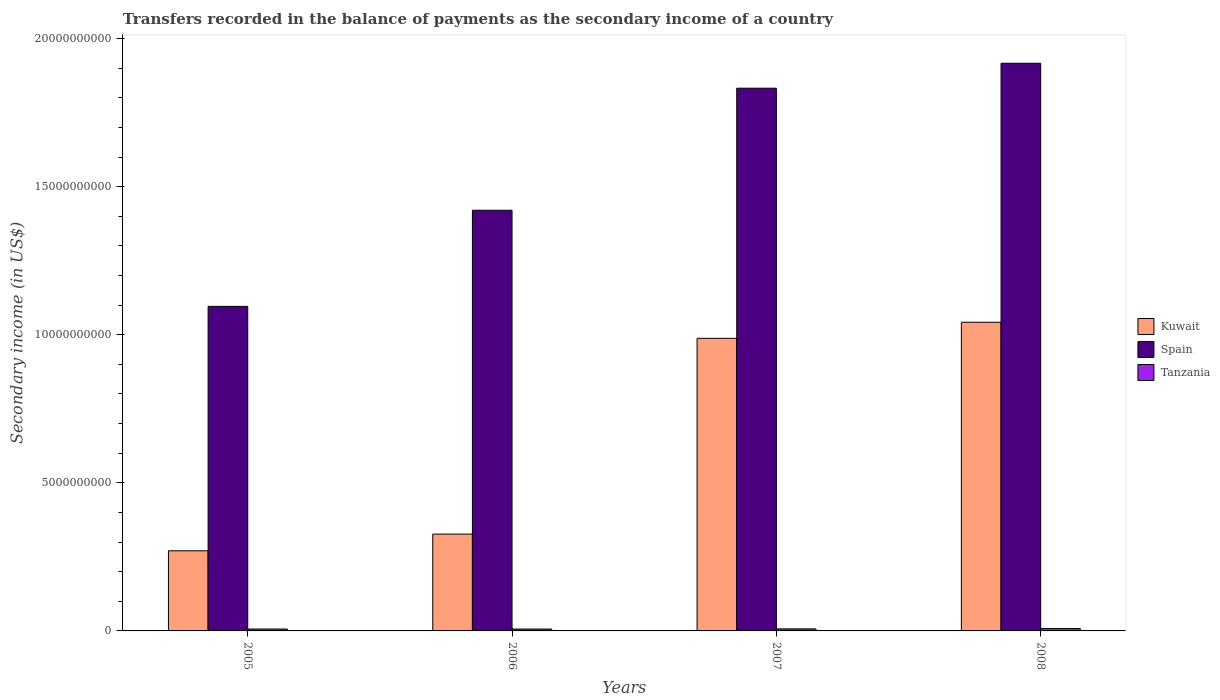How many different coloured bars are there?
Offer a very short reply. 3. Are the number of bars per tick equal to the number of legend labels?
Your answer should be compact. Yes. Are the number of bars on each tick of the X-axis equal?
Make the answer very short. Yes. How many bars are there on the 2nd tick from the left?
Make the answer very short. 3. What is the label of the 1st group of bars from the left?
Keep it short and to the point. 2005. In how many cases, is the number of bars for a given year not equal to the number of legend labels?
Keep it short and to the point. 0. What is the secondary income of in Tanzania in 2006?
Offer a terse response. 6.35e+07. Across all years, what is the maximum secondary income of in Spain?
Make the answer very short. 1.92e+1. Across all years, what is the minimum secondary income of in Tanzania?
Keep it short and to the point. 6.35e+07. In which year was the secondary income of in Spain minimum?
Keep it short and to the point. 2005. What is the total secondary income of in Kuwait in the graph?
Offer a very short reply. 2.63e+1. What is the difference between the secondary income of in Tanzania in 2005 and that in 2006?
Offer a terse response. 4.24e+05. What is the difference between the secondary income of in Kuwait in 2008 and the secondary income of in Spain in 2005?
Offer a terse response. -5.35e+08. What is the average secondary income of in Spain per year?
Provide a succinct answer. 1.57e+1. In the year 2007, what is the difference between the secondary income of in Kuwait and secondary income of in Spain?
Offer a very short reply. -8.45e+09. In how many years, is the secondary income of in Kuwait greater than 1000000000 US$?
Keep it short and to the point. 4. What is the ratio of the secondary income of in Kuwait in 2005 to that in 2007?
Your answer should be very brief. 0.27. Is the secondary income of in Kuwait in 2005 less than that in 2007?
Make the answer very short. Yes. Is the difference between the secondary income of in Kuwait in 2005 and 2007 greater than the difference between the secondary income of in Spain in 2005 and 2007?
Provide a short and direct response. Yes. What is the difference between the highest and the second highest secondary income of in Kuwait?
Offer a very short reply. 5.42e+08. What is the difference between the highest and the lowest secondary income of in Kuwait?
Your answer should be compact. 7.72e+09. Is the sum of the secondary income of in Tanzania in 2005 and 2006 greater than the maximum secondary income of in Kuwait across all years?
Provide a succinct answer. No. What does the 1st bar from the left in 2008 represents?
Make the answer very short. Kuwait. How many bars are there?
Ensure brevity in your answer.  12. Are all the bars in the graph horizontal?
Make the answer very short. No. How many years are there in the graph?
Your answer should be very brief. 4. What is the difference between two consecutive major ticks on the Y-axis?
Your response must be concise. 5.00e+09. Does the graph contain any zero values?
Offer a terse response. No. Does the graph contain grids?
Make the answer very short. No. Where does the legend appear in the graph?
Provide a short and direct response. Center right. What is the title of the graph?
Provide a short and direct response. Transfers recorded in the balance of payments as the secondary income of a country. What is the label or title of the Y-axis?
Ensure brevity in your answer.  Secondary income (in US$). What is the Secondary income (in US$) in Kuwait in 2005?
Give a very brief answer. 2.71e+09. What is the Secondary income (in US$) in Spain in 2005?
Your answer should be very brief. 1.10e+1. What is the Secondary income (in US$) of Tanzania in 2005?
Keep it short and to the point. 6.40e+07. What is the Secondary income (in US$) in Kuwait in 2006?
Provide a succinct answer. 3.27e+09. What is the Secondary income (in US$) in Spain in 2006?
Your answer should be very brief. 1.42e+1. What is the Secondary income (in US$) in Tanzania in 2006?
Offer a very short reply. 6.35e+07. What is the Secondary income (in US$) in Kuwait in 2007?
Give a very brief answer. 9.88e+09. What is the Secondary income (in US$) in Spain in 2007?
Give a very brief answer. 1.83e+1. What is the Secondary income (in US$) in Tanzania in 2007?
Provide a succinct answer. 6.88e+07. What is the Secondary income (in US$) of Kuwait in 2008?
Your answer should be very brief. 1.04e+1. What is the Secondary income (in US$) of Spain in 2008?
Ensure brevity in your answer.  1.92e+1. What is the Secondary income (in US$) of Tanzania in 2008?
Provide a short and direct response. 7.91e+07. Across all years, what is the maximum Secondary income (in US$) in Kuwait?
Ensure brevity in your answer.  1.04e+1. Across all years, what is the maximum Secondary income (in US$) in Spain?
Make the answer very short. 1.92e+1. Across all years, what is the maximum Secondary income (in US$) of Tanzania?
Keep it short and to the point. 7.91e+07. Across all years, what is the minimum Secondary income (in US$) of Kuwait?
Ensure brevity in your answer.  2.71e+09. Across all years, what is the minimum Secondary income (in US$) of Spain?
Your answer should be compact. 1.10e+1. Across all years, what is the minimum Secondary income (in US$) of Tanzania?
Make the answer very short. 6.35e+07. What is the total Secondary income (in US$) in Kuwait in the graph?
Provide a succinct answer. 2.63e+1. What is the total Secondary income (in US$) in Spain in the graph?
Keep it short and to the point. 6.27e+1. What is the total Secondary income (in US$) in Tanzania in the graph?
Offer a terse response. 2.75e+08. What is the difference between the Secondary income (in US$) in Kuwait in 2005 and that in 2006?
Your answer should be compact. -5.64e+08. What is the difference between the Secondary income (in US$) in Spain in 2005 and that in 2006?
Ensure brevity in your answer.  -3.25e+09. What is the difference between the Secondary income (in US$) of Tanzania in 2005 and that in 2006?
Ensure brevity in your answer.  4.24e+05. What is the difference between the Secondary income (in US$) of Kuwait in 2005 and that in 2007?
Make the answer very short. -7.17e+09. What is the difference between the Secondary income (in US$) of Spain in 2005 and that in 2007?
Provide a succinct answer. -7.37e+09. What is the difference between the Secondary income (in US$) in Tanzania in 2005 and that in 2007?
Provide a short and direct response. -4.82e+06. What is the difference between the Secondary income (in US$) in Kuwait in 2005 and that in 2008?
Give a very brief answer. -7.72e+09. What is the difference between the Secondary income (in US$) in Spain in 2005 and that in 2008?
Offer a very short reply. -8.21e+09. What is the difference between the Secondary income (in US$) in Tanzania in 2005 and that in 2008?
Keep it short and to the point. -1.52e+07. What is the difference between the Secondary income (in US$) of Kuwait in 2006 and that in 2007?
Your response must be concise. -6.61e+09. What is the difference between the Secondary income (in US$) in Spain in 2006 and that in 2007?
Your answer should be very brief. -4.12e+09. What is the difference between the Secondary income (in US$) in Tanzania in 2006 and that in 2007?
Provide a succinct answer. -5.25e+06. What is the difference between the Secondary income (in US$) of Kuwait in 2006 and that in 2008?
Offer a very short reply. -7.15e+09. What is the difference between the Secondary income (in US$) of Spain in 2006 and that in 2008?
Provide a succinct answer. -4.96e+09. What is the difference between the Secondary income (in US$) in Tanzania in 2006 and that in 2008?
Keep it short and to the point. -1.56e+07. What is the difference between the Secondary income (in US$) of Kuwait in 2007 and that in 2008?
Provide a short and direct response. -5.42e+08. What is the difference between the Secondary income (in US$) of Spain in 2007 and that in 2008?
Give a very brief answer. -8.42e+08. What is the difference between the Secondary income (in US$) of Tanzania in 2007 and that in 2008?
Keep it short and to the point. -1.04e+07. What is the difference between the Secondary income (in US$) of Kuwait in 2005 and the Secondary income (in US$) of Spain in 2006?
Offer a terse response. -1.15e+1. What is the difference between the Secondary income (in US$) of Kuwait in 2005 and the Secondary income (in US$) of Tanzania in 2006?
Your answer should be compact. 2.64e+09. What is the difference between the Secondary income (in US$) in Spain in 2005 and the Secondary income (in US$) in Tanzania in 2006?
Offer a terse response. 1.09e+1. What is the difference between the Secondary income (in US$) in Kuwait in 2005 and the Secondary income (in US$) in Spain in 2007?
Offer a terse response. -1.56e+1. What is the difference between the Secondary income (in US$) of Kuwait in 2005 and the Secondary income (in US$) of Tanzania in 2007?
Your response must be concise. 2.64e+09. What is the difference between the Secondary income (in US$) in Spain in 2005 and the Secondary income (in US$) in Tanzania in 2007?
Give a very brief answer. 1.09e+1. What is the difference between the Secondary income (in US$) of Kuwait in 2005 and the Secondary income (in US$) of Spain in 2008?
Your answer should be compact. -1.65e+1. What is the difference between the Secondary income (in US$) in Kuwait in 2005 and the Secondary income (in US$) in Tanzania in 2008?
Your answer should be very brief. 2.63e+09. What is the difference between the Secondary income (in US$) in Spain in 2005 and the Secondary income (in US$) in Tanzania in 2008?
Provide a succinct answer. 1.09e+1. What is the difference between the Secondary income (in US$) of Kuwait in 2006 and the Secondary income (in US$) of Spain in 2007?
Your response must be concise. -1.51e+1. What is the difference between the Secondary income (in US$) in Kuwait in 2006 and the Secondary income (in US$) in Tanzania in 2007?
Keep it short and to the point. 3.20e+09. What is the difference between the Secondary income (in US$) of Spain in 2006 and the Secondary income (in US$) of Tanzania in 2007?
Your answer should be very brief. 1.41e+1. What is the difference between the Secondary income (in US$) of Kuwait in 2006 and the Secondary income (in US$) of Spain in 2008?
Keep it short and to the point. -1.59e+1. What is the difference between the Secondary income (in US$) of Kuwait in 2006 and the Secondary income (in US$) of Tanzania in 2008?
Offer a terse response. 3.19e+09. What is the difference between the Secondary income (in US$) of Spain in 2006 and the Secondary income (in US$) of Tanzania in 2008?
Your response must be concise. 1.41e+1. What is the difference between the Secondary income (in US$) in Kuwait in 2007 and the Secondary income (in US$) in Spain in 2008?
Provide a succinct answer. -9.29e+09. What is the difference between the Secondary income (in US$) of Kuwait in 2007 and the Secondary income (in US$) of Tanzania in 2008?
Your answer should be very brief. 9.80e+09. What is the difference between the Secondary income (in US$) in Spain in 2007 and the Secondary income (in US$) in Tanzania in 2008?
Keep it short and to the point. 1.82e+1. What is the average Secondary income (in US$) of Kuwait per year?
Your answer should be compact. 6.57e+09. What is the average Secondary income (in US$) in Spain per year?
Your answer should be compact. 1.57e+1. What is the average Secondary income (in US$) of Tanzania per year?
Keep it short and to the point. 6.89e+07. In the year 2005, what is the difference between the Secondary income (in US$) in Kuwait and Secondary income (in US$) in Spain?
Your answer should be very brief. -8.25e+09. In the year 2005, what is the difference between the Secondary income (in US$) in Kuwait and Secondary income (in US$) in Tanzania?
Ensure brevity in your answer.  2.64e+09. In the year 2005, what is the difference between the Secondary income (in US$) of Spain and Secondary income (in US$) of Tanzania?
Your answer should be very brief. 1.09e+1. In the year 2006, what is the difference between the Secondary income (in US$) of Kuwait and Secondary income (in US$) of Spain?
Your response must be concise. -1.09e+1. In the year 2006, what is the difference between the Secondary income (in US$) of Kuwait and Secondary income (in US$) of Tanzania?
Make the answer very short. 3.21e+09. In the year 2006, what is the difference between the Secondary income (in US$) of Spain and Secondary income (in US$) of Tanzania?
Make the answer very short. 1.41e+1. In the year 2007, what is the difference between the Secondary income (in US$) in Kuwait and Secondary income (in US$) in Spain?
Ensure brevity in your answer.  -8.45e+09. In the year 2007, what is the difference between the Secondary income (in US$) in Kuwait and Secondary income (in US$) in Tanzania?
Offer a terse response. 9.81e+09. In the year 2007, what is the difference between the Secondary income (in US$) of Spain and Secondary income (in US$) of Tanzania?
Give a very brief answer. 1.83e+1. In the year 2008, what is the difference between the Secondary income (in US$) of Kuwait and Secondary income (in US$) of Spain?
Keep it short and to the point. -8.74e+09. In the year 2008, what is the difference between the Secondary income (in US$) in Kuwait and Secondary income (in US$) in Tanzania?
Offer a very short reply. 1.03e+1. In the year 2008, what is the difference between the Secondary income (in US$) in Spain and Secondary income (in US$) in Tanzania?
Keep it short and to the point. 1.91e+1. What is the ratio of the Secondary income (in US$) in Kuwait in 2005 to that in 2006?
Your answer should be compact. 0.83. What is the ratio of the Secondary income (in US$) of Spain in 2005 to that in 2006?
Your response must be concise. 0.77. What is the ratio of the Secondary income (in US$) in Kuwait in 2005 to that in 2007?
Ensure brevity in your answer.  0.27. What is the ratio of the Secondary income (in US$) in Spain in 2005 to that in 2007?
Ensure brevity in your answer.  0.6. What is the ratio of the Secondary income (in US$) of Tanzania in 2005 to that in 2007?
Ensure brevity in your answer.  0.93. What is the ratio of the Secondary income (in US$) in Kuwait in 2005 to that in 2008?
Make the answer very short. 0.26. What is the ratio of the Secondary income (in US$) of Spain in 2005 to that in 2008?
Offer a terse response. 0.57. What is the ratio of the Secondary income (in US$) of Tanzania in 2005 to that in 2008?
Ensure brevity in your answer.  0.81. What is the ratio of the Secondary income (in US$) in Kuwait in 2006 to that in 2007?
Offer a very short reply. 0.33. What is the ratio of the Secondary income (in US$) of Spain in 2006 to that in 2007?
Make the answer very short. 0.78. What is the ratio of the Secondary income (in US$) in Tanzania in 2006 to that in 2007?
Provide a short and direct response. 0.92. What is the ratio of the Secondary income (in US$) in Kuwait in 2006 to that in 2008?
Provide a short and direct response. 0.31. What is the ratio of the Secondary income (in US$) in Spain in 2006 to that in 2008?
Provide a short and direct response. 0.74. What is the ratio of the Secondary income (in US$) of Tanzania in 2006 to that in 2008?
Keep it short and to the point. 0.8. What is the ratio of the Secondary income (in US$) of Kuwait in 2007 to that in 2008?
Give a very brief answer. 0.95. What is the ratio of the Secondary income (in US$) of Spain in 2007 to that in 2008?
Provide a short and direct response. 0.96. What is the ratio of the Secondary income (in US$) in Tanzania in 2007 to that in 2008?
Your answer should be very brief. 0.87. What is the difference between the highest and the second highest Secondary income (in US$) in Kuwait?
Your response must be concise. 5.42e+08. What is the difference between the highest and the second highest Secondary income (in US$) in Spain?
Your response must be concise. 8.42e+08. What is the difference between the highest and the second highest Secondary income (in US$) of Tanzania?
Give a very brief answer. 1.04e+07. What is the difference between the highest and the lowest Secondary income (in US$) in Kuwait?
Your answer should be very brief. 7.72e+09. What is the difference between the highest and the lowest Secondary income (in US$) of Spain?
Your answer should be very brief. 8.21e+09. What is the difference between the highest and the lowest Secondary income (in US$) in Tanzania?
Provide a succinct answer. 1.56e+07. 